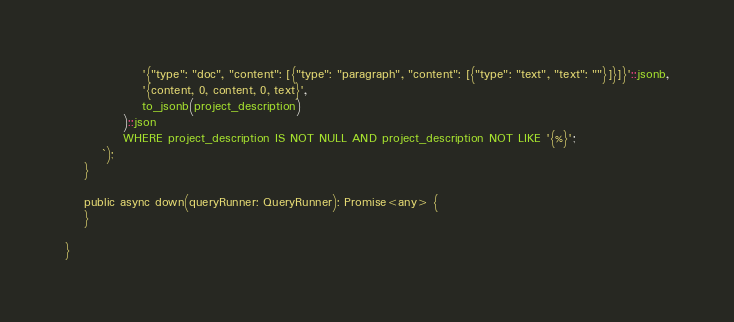Convert code to text. <code><loc_0><loc_0><loc_500><loc_500><_TypeScript_>                '{"type": "doc", "content": [{"type": "paragraph", "content": [{"type": "text", "text": ""}]}]}'::jsonb,
                '{content, 0, content, 0, text}',
                to_jsonb(project_description)
            )::json
            WHERE project_description IS NOT NULL AND project_description NOT LIKE '{%}';
        `);
    }

    public async down(queryRunner: QueryRunner): Promise<any> {
    }

}
</code> 